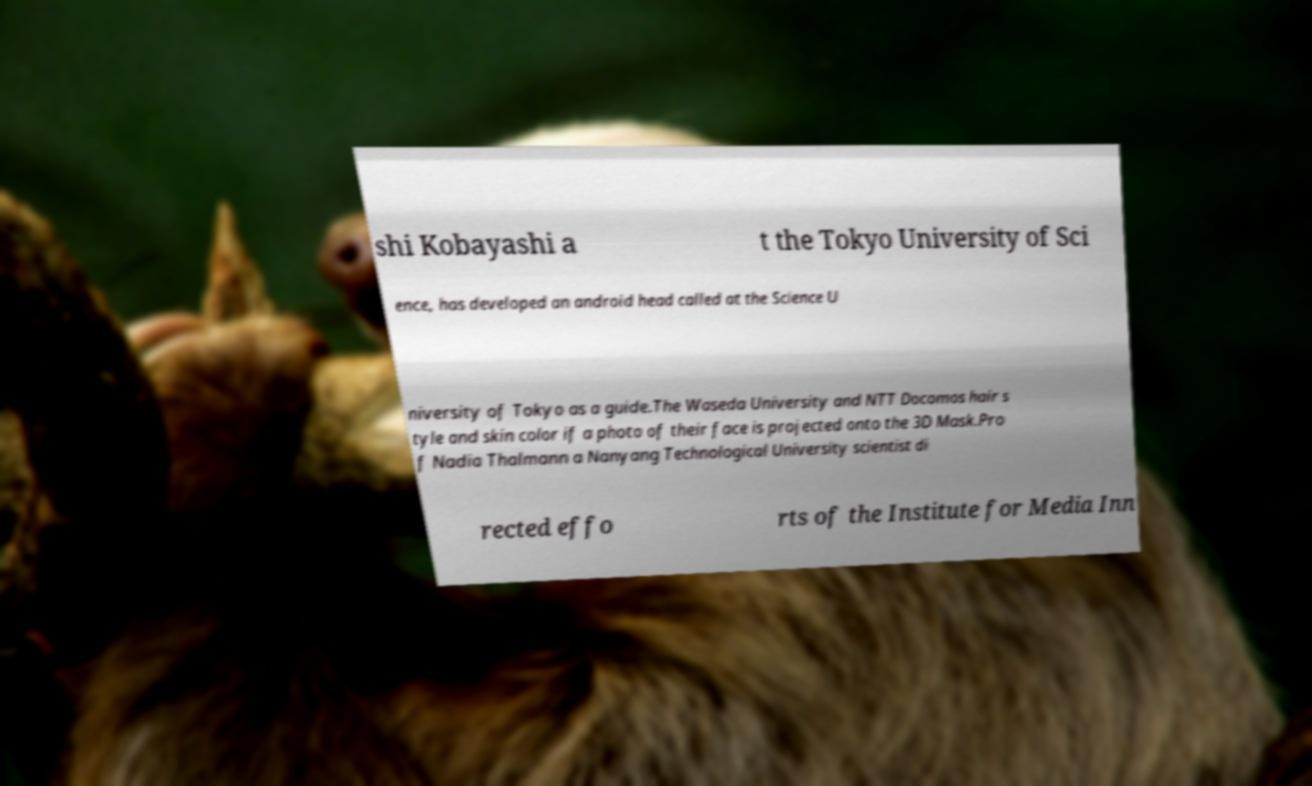What messages or text are displayed in this image? I need them in a readable, typed format. shi Kobayashi a t the Tokyo University of Sci ence, has developed an android head called at the Science U niversity of Tokyo as a guide.The Waseda University and NTT Docomos hair s tyle and skin color if a photo of their face is projected onto the 3D Mask.Pro f Nadia Thalmann a Nanyang Technological University scientist di rected effo rts of the Institute for Media Inn 